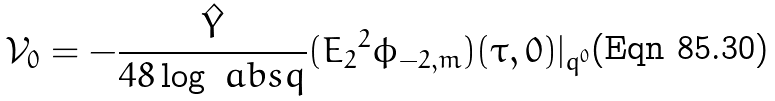Convert formula to latex. <formula><loc_0><loc_0><loc_500><loc_500>\mathcal { V } _ { 0 } = - \frac { \hat { Y } } { 4 8 \log \ a b s { q } } ( { E _ { 2 } } ^ { 2 } \phi _ { - 2 , m } ) ( \tau , 0 ) | _ { q ^ { 0 } }</formula> 